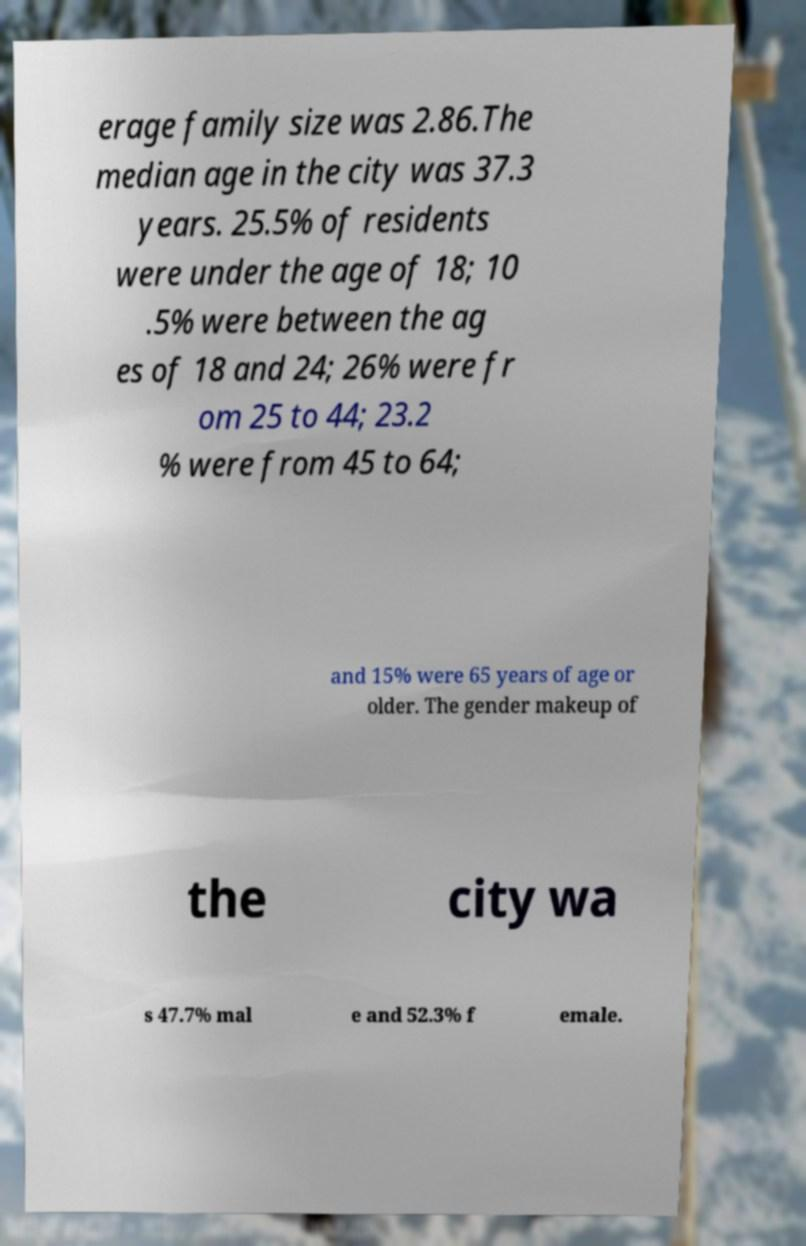For documentation purposes, I need the text within this image transcribed. Could you provide that? erage family size was 2.86.The median age in the city was 37.3 years. 25.5% of residents were under the age of 18; 10 .5% were between the ag es of 18 and 24; 26% were fr om 25 to 44; 23.2 % were from 45 to 64; and 15% were 65 years of age or older. The gender makeup of the city wa s 47.7% mal e and 52.3% f emale. 